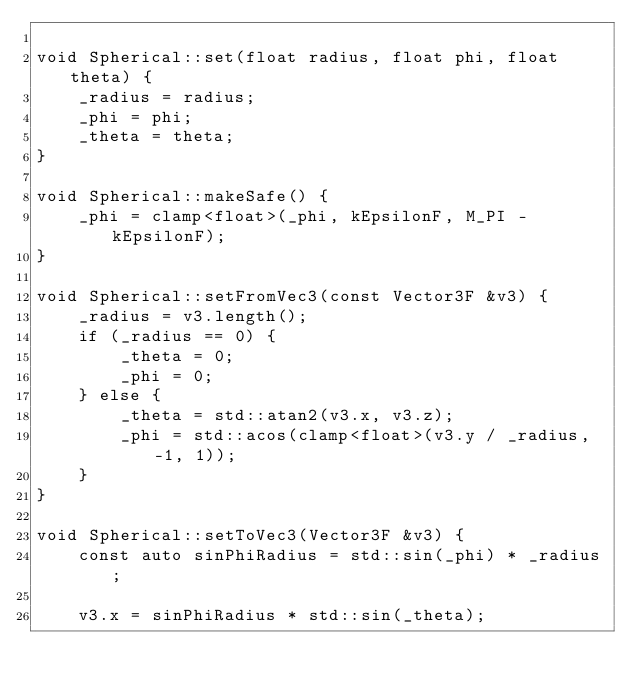<code> <loc_0><loc_0><loc_500><loc_500><_C++_>
void Spherical::set(float radius, float phi, float theta) {
    _radius = radius;
    _phi = phi;
    _theta = theta;
}

void Spherical::makeSafe() {
    _phi = clamp<float>(_phi, kEpsilonF, M_PI - kEpsilonF);
}

void Spherical::setFromVec3(const Vector3F &v3) {
    _radius = v3.length();
    if (_radius == 0) {
        _theta = 0;
        _phi = 0;
    } else {
        _theta = std::atan2(v3.x, v3.z);
        _phi = std::acos(clamp<float>(v3.y / _radius, -1, 1));
    }
}

void Spherical::setToVec3(Vector3F &v3) {
    const auto sinPhiRadius = std::sin(_phi) * _radius;
    
    v3.x = sinPhiRadius * std::sin(_theta);</code> 